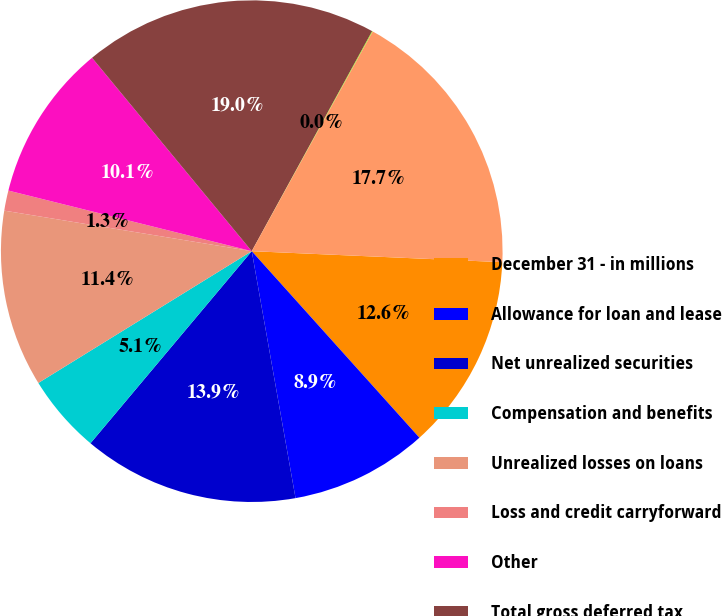<chart> <loc_0><loc_0><loc_500><loc_500><pie_chart><fcel>December 31 - in millions<fcel>Allowance for loan and lease<fcel>Net unrealized securities<fcel>Compensation and benefits<fcel>Unrealized losses on loans<fcel>Loss and credit carryforward<fcel>Other<fcel>Total gross deferred tax<fcel>Valuation allowance<fcel>Total deferred tax assets<nl><fcel>12.65%<fcel>8.86%<fcel>13.91%<fcel>5.08%<fcel>11.39%<fcel>1.3%<fcel>10.13%<fcel>18.96%<fcel>0.04%<fcel>17.69%<nl></chart> 